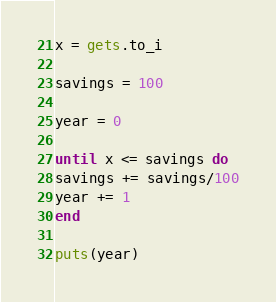<code> <loc_0><loc_0><loc_500><loc_500><_Ruby_>x = gets.to_i

savings = 100
  
year = 0
  
until x <= savings do 
savings += savings/100
year += 1
end 

puts(year)</code> 